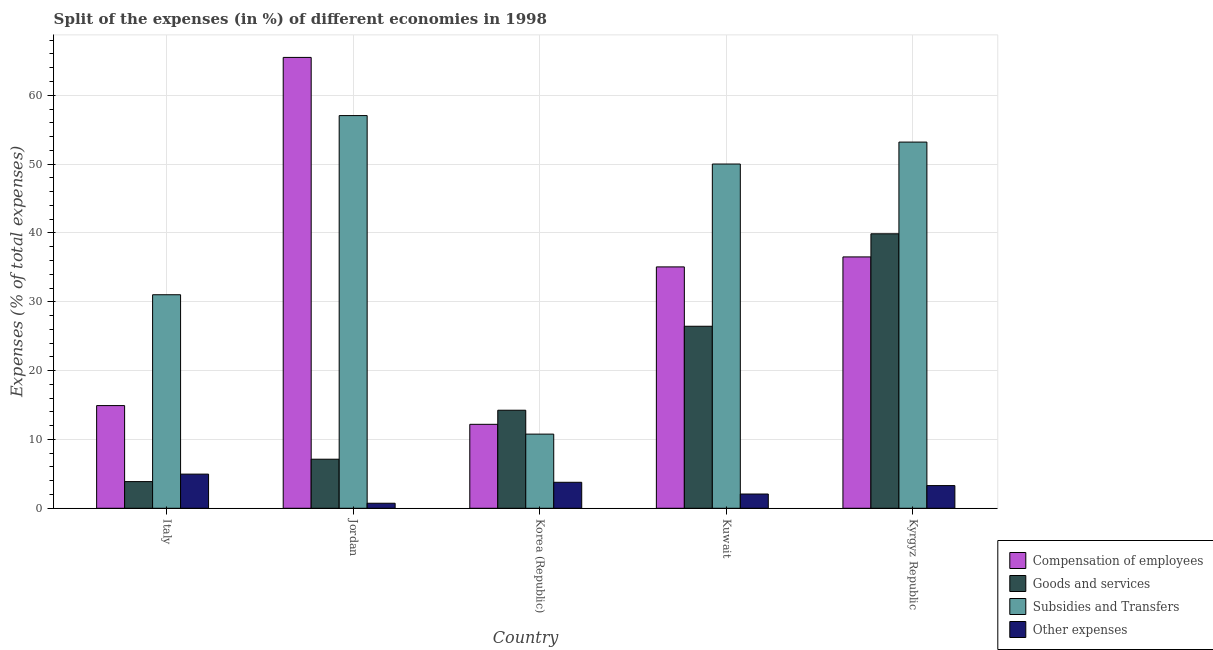Are the number of bars on each tick of the X-axis equal?
Provide a short and direct response. Yes. How many bars are there on the 2nd tick from the left?
Make the answer very short. 4. How many bars are there on the 3rd tick from the right?
Give a very brief answer. 4. What is the label of the 2nd group of bars from the left?
Provide a succinct answer. Jordan. In how many cases, is the number of bars for a given country not equal to the number of legend labels?
Offer a very short reply. 0. What is the percentage of amount spent on subsidies in Jordan?
Ensure brevity in your answer.  57.05. Across all countries, what is the maximum percentage of amount spent on other expenses?
Make the answer very short. 4.96. Across all countries, what is the minimum percentage of amount spent on goods and services?
Your answer should be very brief. 3.87. In which country was the percentage of amount spent on other expenses maximum?
Give a very brief answer. Italy. What is the total percentage of amount spent on subsidies in the graph?
Your answer should be very brief. 202.06. What is the difference between the percentage of amount spent on subsidies in Italy and that in Kyrgyz Republic?
Offer a terse response. -22.18. What is the difference between the percentage of amount spent on other expenses in Kyrgyz Republic and the percentage of amount spent on subsidies in Jordan?
Your answer should be very brief. -53.75. What is the average percentage of amount spent on goods and services per country?
Your response must be concise. 18.31. What is the difference between the percentage of amount spent on compensation of employees and percentage of amount spent on subsidies in Jordan?
Make the answer very short. 8.45. In how many countries, is the percentage of amount spent on other expenses greater than 54 %?
Keep it short and to the point. 0. What is the ratio of the percentage of amount spent on compensation of employees in Italy to that in Korea (Republic)?
Keep it short and to the point. 1.22. Is the percentage of amount spent on subsidies in Jordan less than that in Korea (Republic)?
Provide a succinct answer. No. Is the difference between the percentage of amount spent on compensation of employees in Jordan and Korea (Republic) greater than the difference between the percentage of amount spent on other expenses in Jordan and Korea (Republic)?
Offer a terse response. Yes. What is the difference between the highest and the second highest percentage of amount spent on goods and services?
Give a very brief answer. 13.43. What is the difference between the highest and the lowest percentage of amount spent on subsidies?
Offer a very short reply. 46.28. Is it the case that in every country, the sum of the percentage of amount spent on other expenses and percentage of amount spent on compensation of employees is greater than the sum of percentage of amount spent on subsidies and percentage of amount spent on goods and services?
Your response must be concise. Yes. What does the 4th bar from the left in Korea (Republic) represents?
Your answer should be very brief. Other expenses. What does the 2nd bar from the right in Kuwait represents?
Give a very brief answer. Subsidies and Transfers. What is the difference between two consecutive major ticks on the Y-axis?
Provide a succinct answer. 10. Does the graph contain any zero values?
Make the answer very short. No. Does the graph contain grids?
Your answer should be compact. Yes. Where does the legend appear in the graph?
Your response must be concise. Bottom right. How are the legend labels stacked?
Provide a short and direct response. Vertical. What is the title of the graph?
Provide a succinct answer. Split of the expenses (in %) of different economies in 1998. Does "Sweden" appear as one of the legend labels in the graph?
Offer a terse response. No. What is the label or title of the Y-axis?
Make the answer very short. Expenses (% of total expenses). What is the Expenses (% of total expenses) of Compensation of employees in Italy?
Your answer should be very brief. 14.92. What is the Expenses (% of total expenses) in Goods and services in Italy?
Make the answer very short. 3.87. What is the Expenses (% of total expenses) in Subsidies and Transfers in Italy?
Provide a succinct answer. 31.02. What is the Expenses (% of total expenses) in Other expenses in Italy?
Offer a very short reply. 4.96. What is the Expenses (% of total expenses) of Compensation of employees in Jordan?
Make the answer very short. 65.5. What is the Expenses (% of total expenses) of Goods and services in Jordan?
Give a very brief answer. 7.13. What is the Expenses (% of total expenses) of Subsidies and Transfers in Jordan?
Your response must be concise. 57.05. What is the Expenses (% of total expenses) of Other expenses in Jordan?
Make the answer very short. 0.73. What is the Expenses (% of total expenses) of Compensation of employees in Korea (Republic)?
Provide a short and direct response. 12.2. What is the Expenses (% of total expenses) of Goods and services in Korea (Republic)?
Provide a short and direct response. 14.24. What is the Expenses (% of total expenses) of Subsidies and Transfers in Korea (Republic)?
Your response must be concise. 10.77. What is the Expenses (% of total expenses) of Other expenses in Korea (Republic)?
Make the answer very short. 3.77. What is the Expenses (% of total expenses) in Compensation of employees in Kuwait?
Your response must be concise. 35.07. What is the Expenses (% of total expenses) of Goods and services in Kuwait?
Make the answer very short. 26.44. What is the Expenses (% of total expenses) of Subsidies and Transfers in Kuwait?
Give a very brief answer. 50.01. What is the Expenses (% of total expenses) of Other expenses in Kuwait?
Your response must be concise. 2.07. What is the Expenses (% of total expenses) in Compensation of employees in Kyrgyz Republic?
Ensure brevity in your answer.  36.52. What is the Expenses (% of total expenses) in Goods and services in Kyrgyz Republic?
Make the answer very short. 39.88. What is the Expenses (% of total expenses) in Subsidies and Transfers in Kyrgyz Republic?
Your answer should be compact. 53.2. What is the Expenses (% of total expenses) of Other expenses in Kyrgyz Republic?
Ensure brevity in your answer.  3.29. Across all countries, what is the maximum Expenses (% of total expenses) of Compensation of employees?
Make the answer very short. 65.5. Across all countries, what is the maximum Expenses (% of total expenses) of Goods and services?
Give a very brief answer. 39.88. Across all countries, what is the maximum Expenses (% of total expenses) of Subsidies and Transfers?
Your response must be concise. 57.05. Across all countries, what is the maximum Expenses (% of total expenses) of Other expenses?
Make the answer very short. 4.96. Across all countries, what is the minimum Expenses (% of total expenses) of Compensation of employees?
Your answer should be compact. 12.2. Across all countries, what is the minimum Expenses (% of total expenses) in Goods and services?
Offer a terse response. 3.87. Across all countries, what is the minimum Expenses (% of total expenses) in Subsidies and Transfers?
Give a very brief answer. 10.77. Across all countries, what is the minimum Expenses (% of total expenses) of Other expenses?
Your answer should be very brief. 0.73. What is the total Expenses (% of total expenses) in Compensation of employees in the graph?
Provide a short and direct response. 164.2. What is the total Expenses (% of total expenses) in Goods and services in the graph?
Your answer should be very brief. 91.57. What is the total Expenses (% of total expenses) of Subsidies and Transfers in the graph?
Offer a very short reply. 202.06. What is the total Expenses (% of total expenses) of Other expenses in the graph?
Give a very brief answer. 14.83. What is the difference between the Expenses (% of total expenses) of Compensation of employees in Italy and that in Jordan?
Provide a short and direct response. -50.58. What is the difference between the Expenses (% of total expenses) of Goods and services in Italy and that in Jordan?
Provide a short and direct response. -3.25. What is the difference between the Expenses (% of total expenses) in Subsidies and Transfers in Italy and that in Jordan?
Offer a very short reply. -26.03. What is the difference between the Expenses (% of total expenses) of Other expenses in Italy and that in Jordan?
Provide a short and direct response. 4.23. What is the difference between the Expenses (% of total expenses) of Compensation of employees in Italy and that in Korea (Republic)?
Make the answer very short. 2.72. What is the difference between the Expenses (% of total expenses) in Goods and services in Italy and that in Korea (Republic)?
Your answer should be compact. -10.37. What is the difference between the Expenses (% of total expenses) of Subsidies and Transfers in Italy and that in Korea (Republic)?
Provide a succinct answer. 20.25. What is the difference between the Expenses (% of total expenses) of Other expenses in Italy and that in Korea (Republic)?
Make the answer very short. 1.19. What is the difference between the Expenses (% of total expenses) of Compensation of employees in Italy and that in Kuwait?
Your answer should be compact. -20.15. What is the difference between the Expenses (% of total expenses) of Goods and services in Italy and that in Kuwait?
Provide a short and direct response. -22.57. What is the difference between the Expenses (% of total expenses) in Subsidies and Transfers in Italy and that in Kuwait?
Give a very brief answer. -18.99. What is the difference between the Expenses (% of total expenses) in Other expenses in Italy and that in Kuwait?
Provide a succinct answer. 2.89. What is the difference between the Expenses (% of total expenses) in Compensation of employees in Italy and that in Kyrgyz Republic?
Ensure brevity in your answer.  -21.6. What is the difference between the Expenses (% of total expenses) in Goods and services in Italy and that in Kyrgyz Republic?
Provide a short and direct response. -36. What is the difference between the Expenses (% of total expenses) of Subsidies and Transfers in Italy and that in Kyrgyz Republic?
Provide a short and direct response. -22.18. What is the difference between the Expenses (% of total expenses) in Other expenses in Italy and that in Kyrgyz Republic?
Offer a very short reply. 1.67. What is the difference between the Expenses (% of total expenses) in Compensation of employees in Jordan and that in Korea (Republic)?
Ensure brevity in your answer.  53.3. What is the difference between the Expenses (% of total expenses) of Goods and services in Jordan and that in Korea (Republic)?
Offer a terse response. -7.12. What is the difference between the Expenses (% of total expenses) in Subsidies and Transfers in Jordan and that in Korea (Republic)?
Make the answer very short. 46.28. What is the difference between the Expenses (% of total expenses) in Other expenses in Jordan and that in Korea (Republic)?
Offer a terse response. -3.04. What is the difference between the Expenses (% of total expenses) in Compensation of employees in Jordan and that in Kuwait?
Give a very brief answer. 30.43. What is the difference between the Expenses (% of total expenses) of Goods and services in Jordan and that in Kuwait?
Provide a short and direct response. -19.31. What is the difference between the Expenses (% of total expenses) in Subsidies and Transfers in Jordan and that in Kuwait?
Keep it short and to the point. 7.04. What is the difference between the Expenses (% of total expenses) in Other expenses in Jordan and that in Kuwait?
Provide a succinct answer. -1.34. What is the difference between the Expenses (% of total expenses) in Compensation of employees in Jordan and that in Kyrgyz Republic?
Offer a terse response. 28.98. What is the difference between the Expenses (% of total expenses) of Goods and services in Jordan and that in Kyrgyz Republic?
Give a very brief answer. -32.75. What is the difference between the Expenses (% of total expenses) in Subsidies and Transfers in Jordan and that in Kyrgyz Republic?
Provide a short and direct response. 3.85. What is the difference between the Expenses (% of total expenses) in Other expenses in Jordan and that in Kyrgyz Republic?
Provide a succinct answer. -2.56. What is the difference between the Expenses (% of total expenses) of Compensation of employees in Korea (Republic) and that in Kuwait?
Your response must be concise. -22.87. What is the difference between the Expenses (% of total expenses) in Goods and services in Korea (Republic) and that in Kuwait?
Provide a succinct answer. -12.2. What is the difference between the Expenses (% of total expenses) in Subsidies and Transfers in Korea (Republic) and that in Kuwait?
Ensure brevity in your answer.  -39.24. What is the difference between the Expenses (% of total expenses) in Other expenses in Korea (Republic) and that in Kuwait?
Keep it short and to the point. 1.7. What is the difference between the Expenses (% of total expenses) of Compensation of employees in Korea (Republic) and that in Kyrgyz Republic?
Offer a terse response. -24.32. What is the difference between the Expenses (% of total expenses) in Goods and services in Korea (Republic) and that in Kyrgyz Republic?
Keep it short and to the point. -25.63. What is the difference between the Expenses (% of total expenses) in Subsidies and Transfers in Korea (Republic) and that in Kyrgyz Republic?
Your answer should be compact. -42.43. What is the difference between the Expenses (% of total expenses) in Other expenses in Korea (Republic) and that in Kyrgyz Republic?
Your response must be concise. 0.48. What is the difference between the Expenses (% of total expenses) of Compensation of employees in Kuwait and that in Kyrgyz Republic?
Make the answer very short. -1.45. What is the difference between the Expenses (% of total expenses) in Goods and services in Kuwait and that in Kyrgyz Republic?
Provide a succinct answer. -13.43. What is the difference between the Expenses (% of total expenses) of Subsidies and Transfers in Kuwait and that in Kyrgyz Republic?
Offer a very short reply. -3.19. What is the difference between the Expenses (% of total expenses) of Other expenses in Kuwait and that in Kyrgyz Republic?
Ensure brevity in your answer.  -1.23. What is the difference between the Expenses (% of total expenses) of Compensation of employees in Italy and the Expenses (% of total expenses) of Goods and services in Jordan?
Offer a terse response. 7.79. What is the difference between the Expenses (% of total expenses) of Compensation of employees in Italy and the Expenses (% of total expenses) of Subsidies and Transfers in Jordan?
Ensure brevity in your answer.  -42.13. What is the difference between the Expenses (% of total expenses) of Compensation of employees in Italy and the Expenses (% of total expenses) of Other expenses in Jordan?
Ensure brevity in your answer.  14.19. What is the difference between the Expenses (% of total expenses) of Goods and services in Italy and the Expenses (% of total expenses) of Subsidies and Transfers in Jordan?
Your response must be concise. -53.17. What is the difference between the Expenses (% of total expenses) in Goods and services in Italy and the Expenses (% of total expenses) in Other expenses in Jordan?
Offer a terse response. 3.14. What is the difference between the Expenses (% of total expenses) of Subsidies and Transfers in Italy and the Expenses (% of total expenses) of Other expenses in Jordan?
Your answer should be very brief. 30.29. What is the difference between the Expenses (% of total expenses) in Compensation of employees in Italy and the Expenses (% of total expenses) in Goods and services in Korea (Republic)?
Your answer should be compact. 0.67. What is the difference between the Expenses (% of total expenses) of Compensation of employees in Italy and the Expenses (% of total expenses) of Subsidies and Transfers in Korea (Republic)?
Your response must be concise. 4.15. What is the difference between the Expenses (% of total expenses) in Compensation of employees in Italy and the Expenses (% of total expenses) in Other expenses in Korea (Republic)?
Your answer should be compact. 11.14. What is the difference between the Expenses (% of total expenses) in Goods and services in Italy and the Expenses (% of total expenses) in Subsidies and Transfers in Korea (Republic)?
Make the answer very short. -6.9. What is the difference between the Expenses (% of total expenses) in Goods and services in Italy and the Expenses (% of total expenses) in Other expenses in Korea (Republic)?
Your response must be concise. 0.1. What is the difference between the Expenses (% of total expenses) of Subsidies and Transfers in Italy and the Expenses (% of total expenses) of Other expenses in Korea (Republic)?
Your answer should be very brief. 27.25. What is the difference between the Expenses (% of total expenses) in Compensation of employees in Italy and the Expenses (% of total expenses) in Goods and services in Kuwait?
Provide a succinct answer. -11.52. What is the difference between the Expenses (% of total expenses) in Compensation of employees in Italy and the Expenses (% of total expenses) in Subsidies and Transfers in Kuwait?
Your answer should be very brief. -35.09. What is the difference between the Expenses (% of total expenses) in Compensation of employees in Italy and the Expenses (% of total expenses) in Other expenses in Kuwait?
Your response must be concise. 12.85. What is the difference between the Expenses (% of total expenses) in Goods and services in Italy and the Expenses (% of total expenses) in Subsidies and Transfers in Kuwait?
Keep it short and to the point. -46.14. What is the difference between the Expenses (% of total expenses) of Goods and services in Italy and the Expenses (% of total expenses) of Other expenses in Kuwait?
Your response must be concise. 1.8. What is the difference between the Expenses (% of total expenses) in Subsidies and Transfers in Italy and the Expenses (% of total expenses) in Other expenses in Kuwait?
Your response must be concise. 28.95. What is the difference between the Expenses (% of total expenses) of Compensation of employees in Italy and the Expenses (% of total expenses) of Goods and services in Kyrgyz Republic?
Ensure brevity in your answer.  -24.96. What is the difference between the Expenses (% of total expenses) of Compensation of employees in Italy and the Expenses (% of total expenses) of Subsidies and Transfers in Kyrgyz Republic?
Keep it short and to the point. -38.28. What is the difference between the Expenses (% of total expenses) in Compensation of employees in Italy and the Expenses (% of total expenses) in Other expenses in Kyrgyz Republic?
Your answer should be compact. 11.62. What is the difference between the Expenses (% of total expenses) in Goods and services in Italy and the Expenses (% of total expenses) in Subsidies and Transfers in Kyrgyz Republic?
Offer a terse response. -49.33. What is the difference between the Expenses (% of total expenses) in Goods and services in Italy and the Expenses (% of total expenses) in Other expenses in Kyrgyz Republic?
Offer a very short reply. 0.58. What is the difference between the Expenses (% of total expenses) of Subsidies and Transfers in Italy and the Expenses (% of total expenses) of Other expenses in Kyrgyz Republic?
Your response must be concise. 27.73. What is the difference between the Expenses (% of total expenses) of Compensation of employees in Jordan and the Expenses (% of total expenses) of Goods and services in Korea (Republic)?
Ensure brevity in your answer.  51.26. What is the difference between the Expenses (% of total expenses) in Compensation of employees in Jordan and the Expenses (% of total expenses) in Subsidies and Transfers in Korea (Republic)?
Your answer should be compact. 54.73. What is the difference between the Expenses (% of total expenses) of Compensation of employees in Jordan and the Expenses (% of total expenses) of Other expenses in Korea (Republic)?
Keep it short and to the point. 61.73. What is the difference between the Expenses (% of total expenses) of Goods and services in Jordan and the Expenses (% of total expenses) of Subsidies and Transfers in Korea (Republic)?
Your answer should be very brief. -3.64. What is the difference between the Expenses (% of total expenses) of Goods and services in Jordan and the Expenses (% of total expenses) of Other expenses in Korea (Republic)?
Offer a terse response. 3.35. What is the difference between the Expenses (% of total expenses) in Subsidies and Transfers in Jordan and the Expenses (% of total expenses) in Other expenses in Korea (Republic)?
Offer a very short reply. 53.28. What is the difference between the Expenses (% of total expenses) of Compensation of employees in Jordan and the Expenses (% of total expenses) of Goods and services in Kuwait?
Make the answer very short. 39.06. What is the difference between the Expenses (% of total expenses) in Compensation of employees in Jordan and the Expenses (% of total expenses) in Subsidies and Transfers in Kuwait?
Provide a succinct answer. 15.49. What is the difference between the Expenses (% of total expenses) of Compensation of employees in Jordan and the Expenses (% of total expenses) of Other expenses in Kuwait?
Ensure brevity in your answer.  63.43. What is the difference between the Expenses (% of total expenses) in Goods and services in Jordan and the Expenses (% of total expenses) in Subsidies and Transfers in Kuwait?
Keep it short and to the point. -42.88. What is the difference between the Expenses (% of total expenses) in Goods and services in Jordan and the Expenses (% of total expenses) in Other expenses in Kuwait?
Keep it short and to the point. 5.06. What is the difference between the Expenses (% of total expenses) in Subsidies and Transfers in Jordan and the Expenses (% of total expenses) in Other expenses in Kuwait?
Your answer should be very brief. 54.98. What is the difference between the Expenses (% of total expenses) of Compensation of employees in Jordan and the Expenses (% of total expenses) of Goods and services in Kyrgyz Republic?
Ensure brevity in your answer.  25.62. What is the difference between the Expenses (% of total expenses) of Compensation of employees in Jordan and the Expenses (% of total expenses) of Subsidies and Transfers in Kyrgyz Republic?
Give a very brief answer. 12.3. What is the difference between the Expenses (% of total expenses) of Compensation of employees in Jordan and the Expenses (% of total expenses) of Other expenses in Kyrgyz Republic?
Offer a terse response. 62.21. What is the difference between the Expenses (% of total expenses) in Goods and services in Jordan and the Expenses (% of total expenses) in Subsidies and Transfers in Kyrgyz Republic?
Ensure brevity in your answer.  -46.07. What is the difference between the Expenses (% of total expenses) in Goods and services in Jordan and the Expenses (% of total expenses) in Other expenses in Kyrgyz Republic?
Ensure brevity in your answer.  3.83. What is the difference between the Expenses (% of total expenses) in Subsidies and Transfers in Jordan and the Expenses (% of total expenses) in Other expenses in Kyrgyz Republic?
Offer a very short reply. 53.75. What is the difference between the Expenses (% of total expenses) of Compensation of employees in Korea (Republic) and the Expenses (% of total expenses) of Goods and services in Kuwait?
Give a very brief answer. -14.25. What is the difference between the Expenses (% of total expenses) of Compensation of employees in Korea (Republic) and the Expenses (% of total expenses) of Subsidies and Transfers in Kuwait?
Keep it short and to the point. -37.82. What is the difference between the Expenses (% of total expenses) in Compensation of employees in Korea (Republic) and the Expenses (% of total expenses) in Other expenses in Kuwait?
Your answer should be very brief. 10.13. What is the difference between the Expenses (% of total expenses) of Goods and services in Korea (Republic) and the Expenses (% of total expenses) of Subsidies and Transfers in Kuwait?
Your answer should be compact. -35.77. What is the difference between the Expenses (% of total expenses) in Goods and services in Korea (Republic) and the Expenses (% of total expenses) in Other expenses in Kuwait?
Your answer should be very brief. 12.18. What is the difference between the Expenses (% of total expenses) in Subsidies and Transfers in Korea (Republic) and the Expenses (% of total expenses) in Other expenses in Kuwait?
Your answer should be very brief. 8.7. What is the difference between the Expenses (% of total expenses) of Compensation of employees in Korea (Republic) and the Expenses (% of total expenses) of Goods and services in Kyrgyz Republic?
Make the answer very short. -27.68. What is the difference between the Expenses (% of total expenses) in Compensation of employees in Korea (Republic) and the Expenses (% of total expenses) in Subsidies and Transfers in Kyrgyz Republic?
Offer a very short reply. -41. What is the difference between the Expenses (% of total expenses) in Compensation of employees in Korea (Republic) and the Expenses (% of total expenses) in Other expenses in Kyrgyz Republic?
Your answer should be very brief. 8.9. What is the difference between the Expenses (% of total expenses) of Goods and services in Korea (Republic) and the Expenses (% of total expenses) of Subsidies and Transfers in Kyrgyz Republic?
Your answer should be very brief. -38.96. What is the difference between the Expenses (% of total expenses) in Goods and services in Korea (Republic) and the Expenses (% of total expenses) in Other expenses in Kyrgyz Republic?
Give a very brief answer. 10.95. What is the difference between the Expenses (% of total expenses) in Subsidies and Transfers in Korea (Republic) and the Expenses (% of total expenses) in Other expenses in Kyrgyz Republic?
Keep it short and to the point. 7.48. What is the difference between the Expenses (% of total expenses) in Compensation of employees in Kuwait and the Expenses (% of total expenses) in Goods and services in Kyrgyz Republic?
Make the answer very short. -4.81. What is the difference between the Expenses (% of total expenses) of Compensation of employees in Kuwait and the Expenses (% of total expenses) of Subsidies and Transfers in Kyrgyz Republic?
Your answer should be very brief. -18.13. What is the difference between the Expenses (% of total expenses) of Compensation of employees in Kuwait and the Expenses (% of total expenses) of Other expenses in Kyrgyz Republic?
Offer a terse response. 31.77. What is the difference between the Expenses (% of total expenses) of Goods and services in Kuwait and the Expenses (% of total expenses) of Subsidies and Transfers in Kyrgyz Republic?
Provide a succinct answer. -26.76. What is the difference between the Expenses (% of total expenses) in Goods and services in Kuwait and the Expenses (% of total expenses) in Other expenses in Kyrgyz Republic?
Make the answer very short. 23.15. What is the difference between the Expenses (% of total expenses) of Subsidies and Transfers in Kuwait and the Expenses (% of total expenses) of Other expenses in Kyrgyz Republic?
Your response must be concise. 46.72. What is the average Expenses (% of total expenses) in Compensation of employees per country?
Keep it short and to the point. 32.84. What is the average Expenses (% of total expenses) of Goods and services per country?
Offer a terse response. 18.31. What is the average Expenses (% of total expenses) of Subsidies and Transfers per country?
Make the answer very short. 40.41. What is the average Expenses (% of total expenses) in Other expenses per country?
Make the answer very short. 2.97. What is the difference between the Expenses (% of total expenses) of Compensation of employees and Expenses (% of total expenses) of Goods and services in Italy?
Offer a terse response. 11.04. What is the difference between the Expenses (% of total expenses) in Compensation of employees and Expenses (% of total expenses) in Subsidies and Transfers in Italy?
Your response must be concise. -16.1. What is the difference between the Expenses (% of total expenses) in Compensation of employees and Expenses (% of total expenses) in Other expenses in Italy?
Offer a terse response. 9.96. What is the difference between the Expenses (% of total expenses) in Goods and services and Expenses (% of total expenses) in Subsidies and Transfers in Italy?
Keep it short and to the point. -27.15. What is the difference between the Expenses (% of total expenses) in Goods and services and Expenses (% of total expenses) in Other expenses in Italy?
Make the answer very short. -1.09. What is the difference between the Expenses (% of total expenses) of Subsidies and Transfers and Expenses (% of total expenses) of Other expenses in Italy?
Provide a succinct answer. 26.06. What is the difference between the Expenses (% of total expenses) in Compensation of employees and Expenses (% of total expenses) in Goods and services in Jordan?
Your response must be concise. 58.37. What is the difference between the Expenses (% of total expenses) of Compensation of employees and Expenses (% of total expenses) of Subsidies and Transfers in Jordan?
Provide a succinct answer. 8.45. What is the difference between the Expenses (% of total expenses) in Compensation of employees and Expenses (% of total expenses) in Other expenses in Jordan?
Your answer should be very brief. 64.77. What is the difference between the Expenses (% of total expenses) in Goods and services and Expenses (% of total expenses) in Subsidies and Transfers in Jordan?
Provide a short and direct response. -49.92. What is the difference between the Expenses (% of total expenses) in Goods and services and Expenses (% of total expenses) in Other expenses in Jordan?
Ensure brevity in your answer.  6.4. What is the difference between the Expenses (% of total expenses) in Subsidies and Transfers and Expenses (% of total expenses) in Other expenses in Jordan?
Ensure brevity in your answer.  56.32. What is the difference between the Expenses (% of total expenses) of Compensation of employees and Expenses (% of total expenses) of Goods and services in Korea (Republic)?
Keep it short and to the point. -2.05. What is the difference between the Expenses (% of total expenses) in Compensation of employees and Expenses (% of total expenses) in Subsidies and Transfers in Korea (Republic)?
Provide a succinct answer. 1.42. What is the difference between the Expenses (% of total expenses) in Compensation of employees and Expenses (% of total expenses) in Other expenses in Korea (Republic)?
Offer a very short reply. 8.42. What is the difference between the Expenses (% of total expenses) of Goods and services and Expenses (% of total expenses) of Subsidies and Transfers in Korea (Republic)?
Offer a very short reply. 3.47. What is the difference between the Expenses (% of total expenses) in Goods and services and Expenses (% of total expenses) in Other expenses in Korea (Republic)?
Provide a succinct answer. 10.47. What is the difference between the Expenses (% of total expenses) of Subsidies and Transfers and Expenses (% of total expenses) of Other expenses in Korea (Republic)?
Ensure brevity in your answer.  7. What is the difference between the Expenses (% of total expenses) in Compensation of employees and Expenses (% of total expenses) in Goods and services in Kuwait?
Ensure brevity in your answer.  8.62. What is the difference between the Expenses (% of total expenses) of Compensation of employees and Expenses (% of total expenses) of Subsidies and Transfers in Kuwait?
Give a very brief answer. -14.95. What is the difference between the Expenses (% of total expenses) of Compensation of employees and Expenses (% of total expenses) of Other expenses in Kuwait?
Your response must be concise. 33. What is the difference between the Expenses (% of total expenses) in Goods and services and Expenses (% of total expenses) in Subsidies and Transfers in Kuwait?
Your answer should be compact. -23.57. What is the difference between the Expenses (% of total expenses) of Goods and services and Expenses (% of total expenses) of Other expenses in Kuwait?
Offer a very short reply. 24.37. What is the difference between the Expenses (% of total expenses) in Subsidies and Transfers and Expenses (% of total expenses) in Other expenses in Kuwait?
Offer a very short reply. 47.94. What is the difference between the Expenses (% of total expenses) of Compensation of employees and Expenses (% of total expenses) of Goods and services in Kyrgyz Republic?
Your answer should be compact. -3.36. What is the difference between the Expenses (% of total expenses) of Compensation of employees and Expenses (% of total expenses) of Subsidies and Transfers in Kyrgyz Republic?
Give a very brief answer. -16.68. What is the difference between the Expenses (% of total expenses) of Compensation of employees and Expenses (% of total expenses) of Other expenses in Kyrgyz Republic?
Give a very brief answer. 33.22. What is the difference between the Expenses (% of total expenses) of Goods and services and Expenses (% of total expenses) of Subsidies and Transfers in Kyrgyz Republic?
Give a very brief answer. -13.32. What is the difference between the Expenses (% of total expenses) in Goods and services and Expenses (% of total expenses) in Other expenses in Kyrgyz Republic?
Keep it short and to the point. 36.58. What is the difference between the Expenses (% of total expenses) in Subsidies and Transfers and Expenses (% of total expenses) in Other expenses in Kyrgyz Republic?
Offer a very short reply. 49.91. What is the ratio of the Expenses (% of total expenses) of Compensation of employees in Italy to that in Jordan?
Your answer should be compact. 0.23. What is the ratio of the Expenses (% of total expenses) of Goods and services in Italy to that in Jordan?
Provide a short and direct response. 0.54. What is the ratio of the Expenses (% of total expenses) in Subsidies and Transfers in Italy to that in Jordan?
Ensure brevity in your answer.  0.54. What is the ratio of the Expenses (% of total expenses) of Other expenses in Italy to that in Jordan?
Provide a succinct answer. 6.79. What is the ratio of the Expenses (% of total expenses) in Compensation of employees in Italy to that in Korea (Republic)?
Offer a very short reply. 1.22. What is the ratio of the Expenses (% of total expenses) of Goods and services in Italy to that in Korea (Republic)?
Ensure brevity in your answer.  0.27. What is the ratio of the Expenses (% of total expenses) of Subsidies and Transfers in Italy to that in Korea (Republic)?
Your answer should be compact. 2.88. What is the ratio of the Expenses (% of total expenses) in Other expenses in Italy to that in Korea (Republic)?
Ensure brevity in your answer.  1.31. What is the ratio of the Expenses (% of total expenses) of Compensation of employees in Italy to that in Kuwait?
Give a very brief answer. 0.43. What is the ratio of the Expenses (% of total expenses) of Goods and services in Italy to that in Kuwait?
Your answer should be very brief. 0.15. What is the ratio of the Expenses (% of total expenses) of Subsidies and Transfers in Italy to that in Kuwait?
Offer a terse response. 0.62. What is the ratio of the Expenses (% of total expenses) in Other expenses in Italy to that in Kuwait?
Keep it short and to the point. 2.4. What is the ratio of the Expenses (% of total expenses) in Compensation of employees in Italy to that in Kyrgyz Republic?
Keep it short and to the point. 0.41. What is the ratio of the Expenses (% of total expenses) in Goods and services in Italy to that in Kyrgyz Republic?
Provide a short and direct response. 0.1. What is the ratio of the Expenses (% of total expenses) of Subsidies and Transfers in Italy to that in Kyrgyz Republic?
Give a very brief answer. 0.58. What is the ratio of the Expenses (% of total expenses) in Other expenses in Italy to that in Kyrgyz Republic?
Your answer should be very brief. 1.51. What is the ratio of the Expenses (% of total expenses) of Compensation of employees in Jordan to that in Korea (Republic)?
Ensure brevity in your answer.  5.37. What is the ratio of the Expenses (% of total expenses) in Goods and services in Jordan to that in Korea (Republic)?
Keep it short and to the point. 0.5. What is the ratio of the Expenses (% of total expenses) in Subsidies and Transfers in Jordan to that in Korea (Republic)?
Provide a short and direct response. 5.3. What is the ratio of the Expenses (% of total expenses) of Other expenses in Jordan to that in Korea (Republic)?
Keep it short and to the point. 0.19. What is the ratio of the Expenses (% of total expenses) of Compensation of employees in Jordan to that in Kuwait?
Your answer should be compact. 1.87. What is the ratio of the Expenses (% of total expenses) in Goods and services in Jordan to that in Kuwait?
Provide a succinct answer. 0.27. What is the ratio of the Expenses (% of total expenses) in Subsidies and Transfers in Jordan to that in Kuwait?
Ensure brevity in your answer.  1.14. What is the ratio of the Expenses (% of total expenses) of Other expenses in Jordan to that in Kuwait?
Make the answer very short. 0.35. What is the ratio of the Expenses (% of total expenses) of Compensation of employees in Jordan to that in Kyrgyz Republic?
Ensure brevity in your answer.  1.79. What is the ratio of the Expenses (% of total expenses) of Goods and services in Jordan to that in Kyrgyz Republic?
Ensure brevity in your answer.  0.18. What is the ratio of the Expenses (% of total expenses) in Subsidies and Transfers in Jordan to that in Kyrgyz Republic?
Provide a short and direct response. 1.07. What is the ratio of the Expenses (% of total expenses) of Other expenses in Jordan to that in Kyrgyz Republic?
Your answer should be very brief. 0.22. What is the ratio of the Expenses (% of total expenses) in Compensation of employees in Korea (Republic) to that in Kuwait?
Offer a terse response. 0.35. What is the ratio of the Expenses (% of total expenses) of Goods and services in Korea (Republic) to that in Kuwait?
Keep it short and to the point. 0.54. What is the ratio of the Expenses (% of total expenses) in Subsidies and Transfers in Korea (Republic) to that in Kuwait?
Your response must be concise. 0.22. What is the ratio of the Expenses (% of total expenses) in Other expenses in Korea (Republic) to that in Kuwait?
Make the answer very short. 1.82. What is the ratio of the Expenses (% of total expenses) in Compensation of employees in Korea (Republic) to that in Kyrgyz Republic?
Provide a short and direct response. 0.33. What is the ratio of the Expenses (% of total expenses) of Goods and services in Korea (Republic) to that in Kyrgyz Republic?
Provide a short and direct response. 0.36. What is the ratio of the Expenses (% of total expenses) in Subsidies and Transfers in Korea (Republic) to that in Kyrgyz Republic?
Your response must be concise. 0.2. What is the ratio of the Expenses (% of total expenses) in Other expenses in Korea (Republic) to that in Kyrgyz Republic?
Provide a short and direct response. 1.15. What is the ratio of the Expenses (% of total expenses) of Compensation of employees in Kuwait to that in Kyrgyz Republic?
Make the answer very short. 0.96. What is the ratio of the Expenses (% of total expenses) of Goods and services in Kuwait to that in Kyrgyz Republic?
Keep it short and to the point. 0.66. What is the ratio of the Expenses (% of total expenses) of Subsidies and Transfers in Kuwait to that in Kyrgyz Republic?
Your answer should be very brief. 0.94. What is the ratio of the Expenses (% of total expenses) of Other expenses in Kuwait to that in Kyrgyz Republic?
Offer a very short reply. 0.63. What is the difference between the highest and the second highest Expenses (% of total expenses) of Compensation of employees?
Provide a short and direct response. 28.98. What is the difference between the highest and the second highest Expenses (% of total expenses) of Goods and services?
Your answer should be very brief. 13.43. What is the difference between the highest and the second highest Expenses (% of total expenses) of Subsidies and Transfers?
Provide a succinct answer. 3.85. What is the difference between the highest and the second highest Expenses (% of total expenses) of Other expenses?
Keep it short and to the point. 1.19. What is the difference between the highest and the lowest Expenses (% of total expenses) in Compensation of employees?
Keep it short and to the point. 53.3. What is the difference between the highest and the lowest Expenses (% of total expenses) of Goods and services?
Your response must be concise. 36. What is the difference between the highest and the lowest Expenses (% of total expenses) of Subsidies and Transfers?
Your answer should be compact. 46.28. What is the difference between the highest and the lowest Expenses (% of total expenses) in Other expenses?
Make the answer very short. 4.23. 